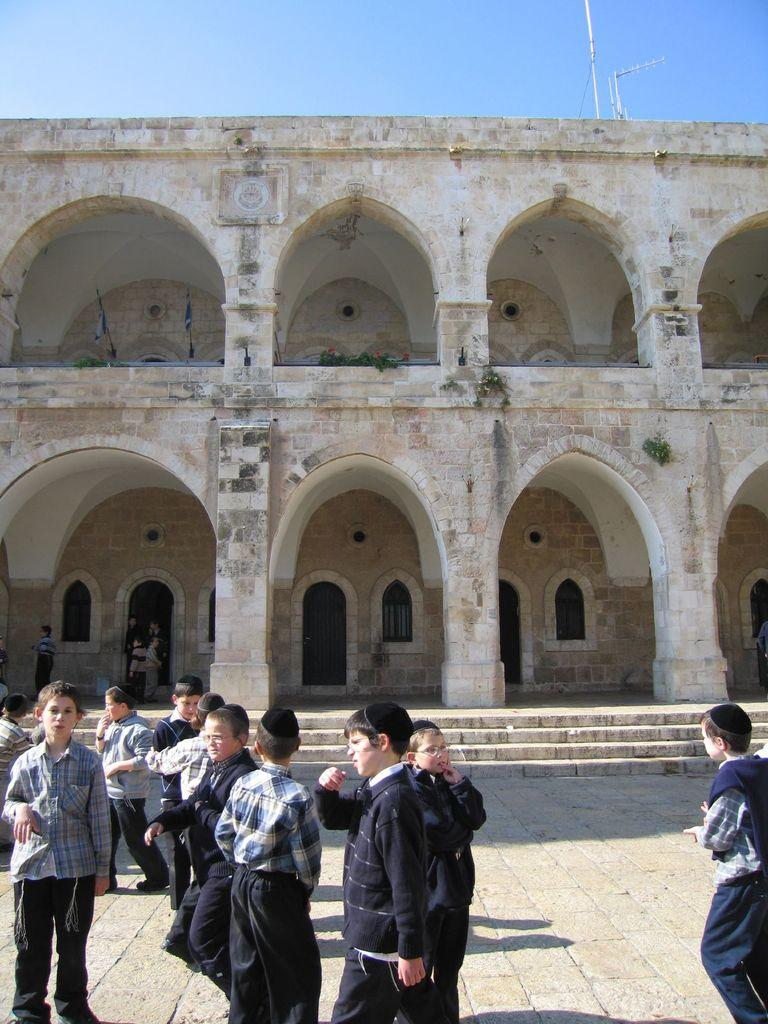What type of structure is visible in the image? There is a building in the image. What else can be seen in the image besides the building? There are flags and boys standing in the image. Can you describe the boys in the image? Some of the boys are wearing caps. How would you describe the sky in the image? The sky is blue and cloudy. What type of zipper can be seen on the boys' clothing in the image? There is no mention of zippers on the boys' clothing in the image. Can you tell me which animals are present in the zoo in the image? There is no zoo present in the image. 